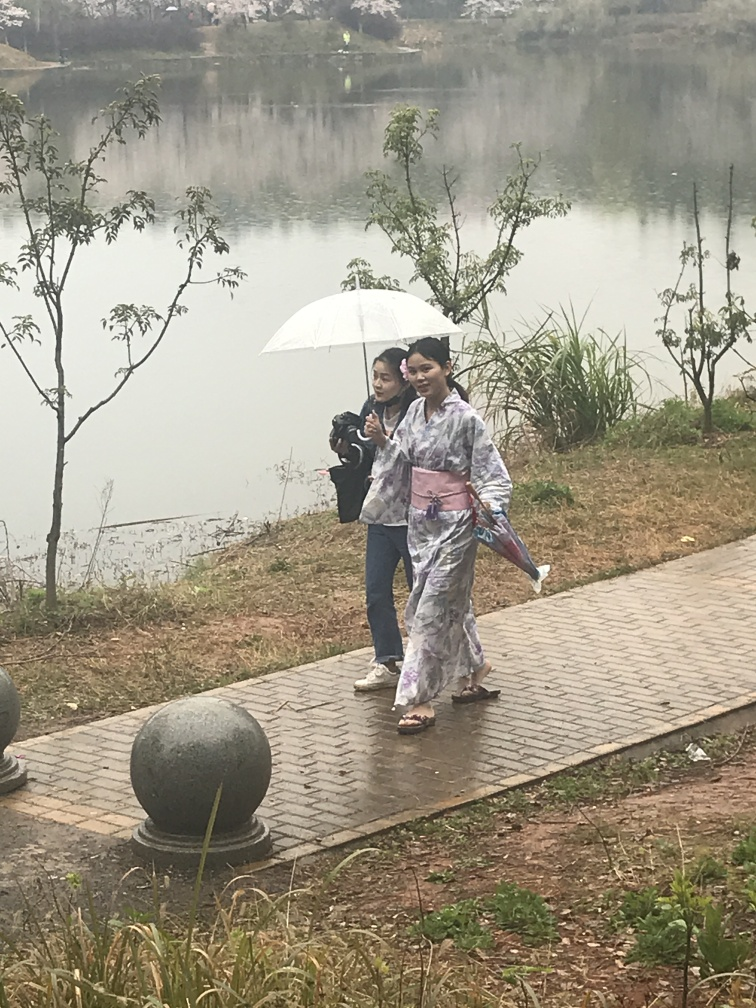Is there any issue with exposure? The image's exposure appears to be appropriate, with adequate balance between light and dark areas, preserving detail throughout the scene. 